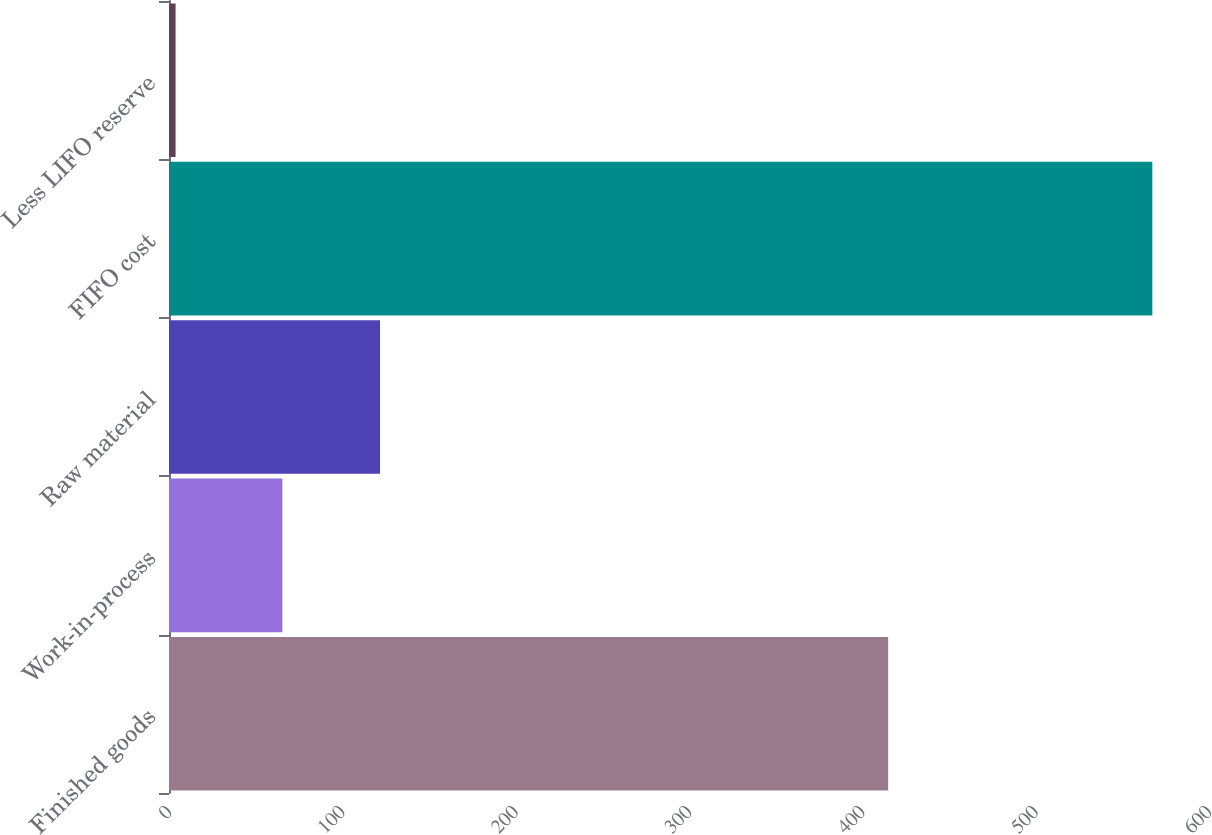<chart> <loc_0><loc_0><loc_500><loc_500><bar_chart><fcel>Finished goods<fcel>Work-in-process<fcel>Raw material<fcel>FIFO cost<fcel>Less LIFO reserve<nl><fcel>414.9<fcel>65.4<fcel>121.75<fcel>567.3<fcel>3.8<nl></chart> 